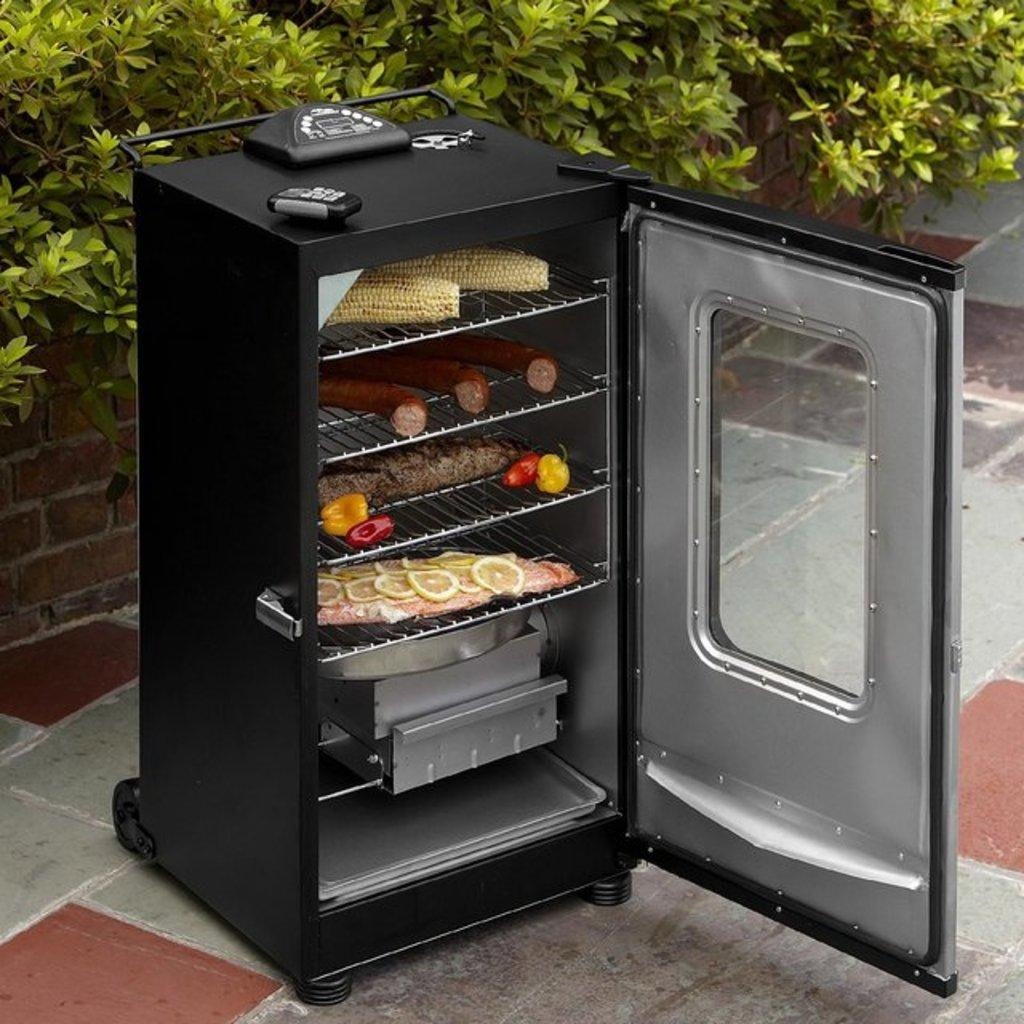What appliance can be seen in the image? There is a microwave oven in the image. What is inside the microwave oven? The microwave oven contains corn, hot dogs, and other food items. What type of vegetation is visible at the top of the image? There are plants visible at the top of the image. What type of structure is in the center of the image? There is a brick wall in the center of the image. How many quince are on the brick wall in the image? There are no quince visible in the image, and the brick wall does not have any fruits or objects on it. 